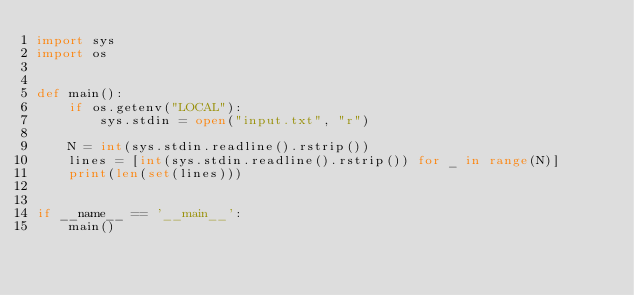Convert code to text. <code><loc_0><loc_0><loc_500><loc_500><_Python_>import sys
import os


def main():
    if os.getenv("LOCAL"):
        sys.stdin = open("input.txt", "r")

    N = int(sys.stdin.readline().rstrip())
    lines = [int(sys.stdin.readline().rstrip()) for _ in range(N)]
    print(len(set(lines)))


if __name__ == '__main__':
    main()
</code> 